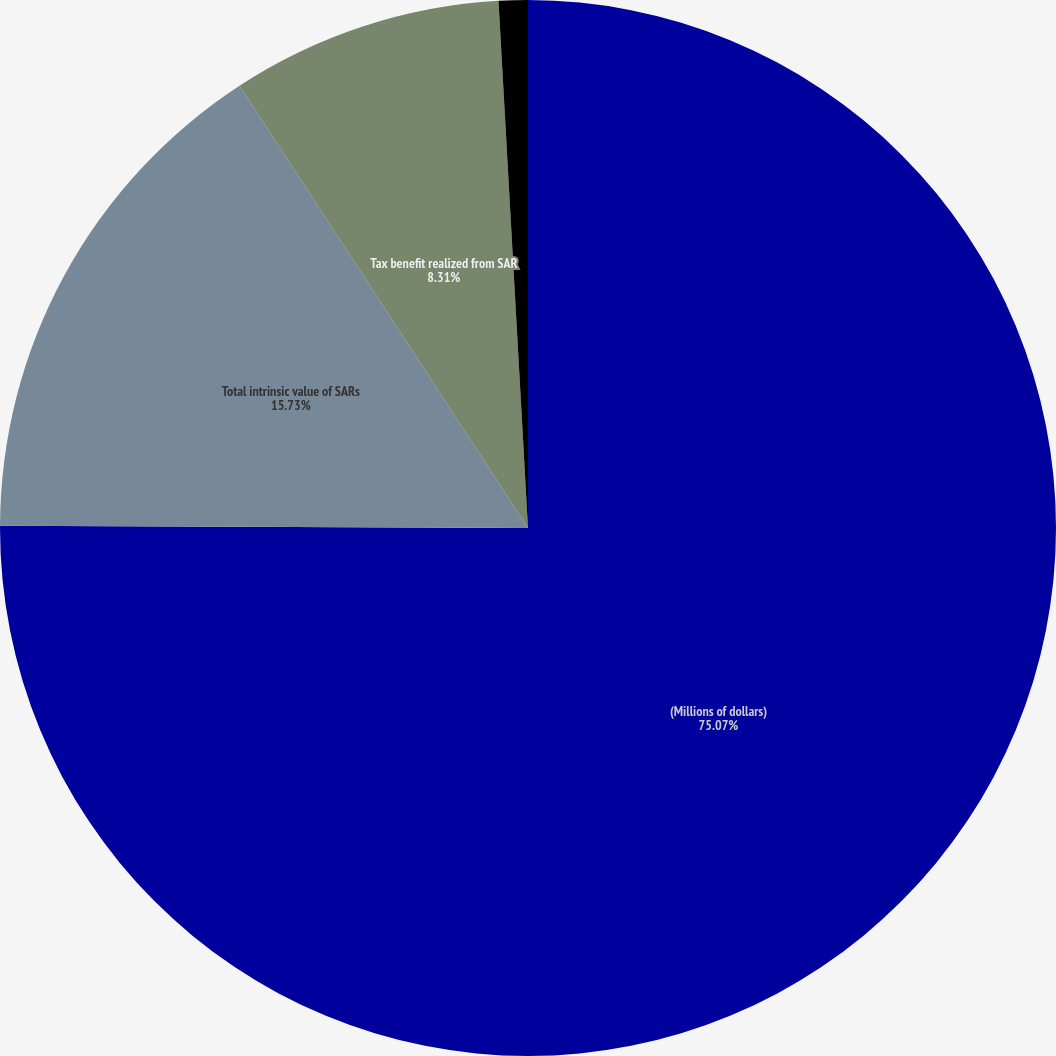Convert chart. <chart><loc_0><loc_0><loc_500><loc_500><pie_chart><fcel>(Millions of dollars)<fcel>Total intrinsic value of SARs<fcel>Tax benefit realized from SAR<fcel>Total fair value of SARs<nl><fcel>75.07%<fcel>15.73%<fcel>8.31%<fcel>0.89%<nl></chart> 